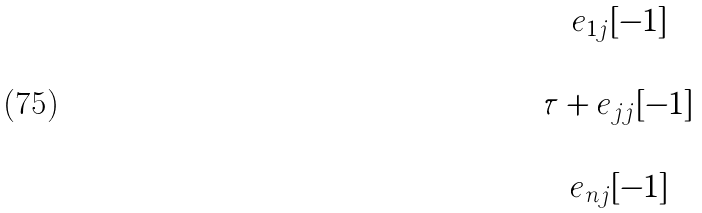<formula> <loc_0><loc_0><loc_500><loc_500>\begin{matrix} \cdots & e _ { 1 j } [ - 1 ] & \cdots \\ \cdots & \cdots & \cdots \\ \cdots & \tau + e _ { j j } [ - 1 ] & \cdots \\ \cdots & \cdots & \cdots \\ \cdots & e _ { n j } [ - 1 ] & \cdots \end{matrix}</formula> 